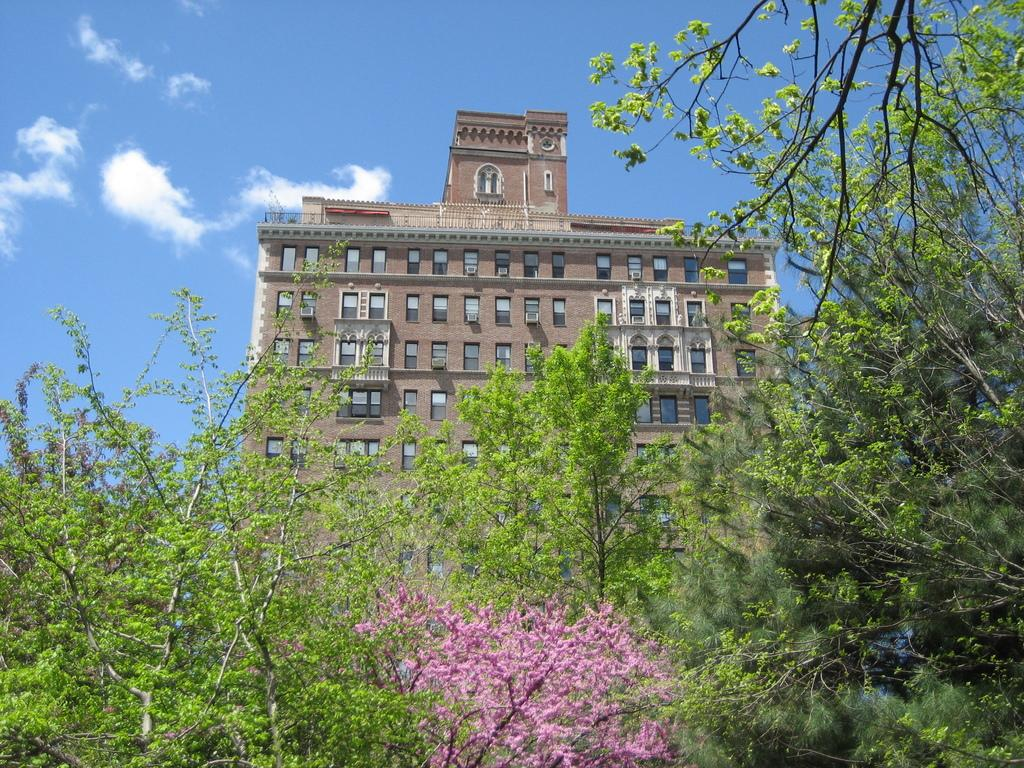What is the main subject in the center of the image? There is a building in the center of the image. What type of natural elements can be seen at the bottom of the image? Trees are visible at the bottom of the image. What part of the environment is visible in the background of the image? The sky is visible in the background of the image. What type of pet can be seen taking a bath in the image? There is no pet or bath present in the image; it features a building, trees, and the sky. What type of appliance is visible in the image? There is no appliance present in the image. 